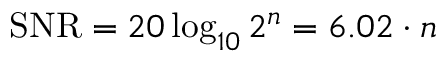<formula> <loc_0><loc_0><loc_500><loc_500>S N R = 2 0 \log _ { 1 0 } 2 ^ { n } = 6 . 0 2 \cdot n</formula> 